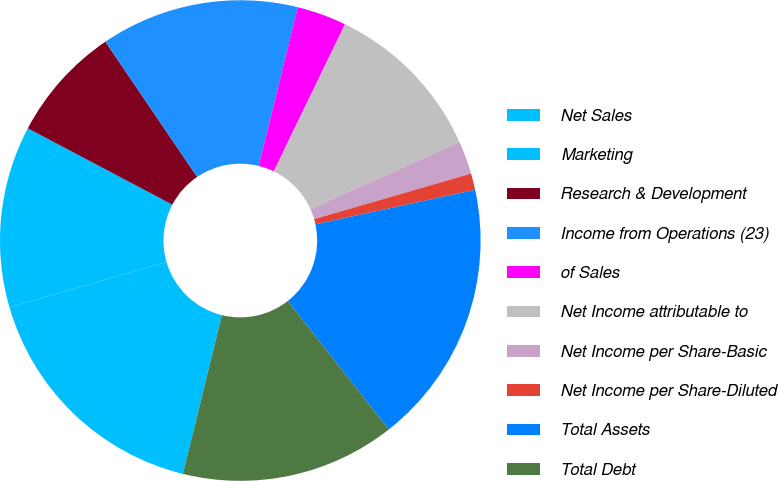Convert chart. <chart><loc_0><loc_0><loc_500><loc_500><pie_chart><fcel>Net Sales<fcel>Marketing<fcel>Research & Development<fcel>Income from Operations (23)<fcel>of Sales<fcel>Net Income attributable to<fcel>Net Income per Share-Basic<fcel>Net Income per Share-Diluted<fcel>Total Assets<fcel>Total Debt<nl><fcel>16.67%<fcel>12.22%<fcel>7.78%<fcel>13.33%<fcel>3.33%<fcel>11.11%<fcel>2.22%<fcel>1.11%<fcel>17.78%<fcel>14.44%<nl></chart> 